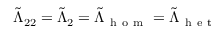<formula> <loc_0><loc_0><loc_500><loc_500>\tilde { \Lambda } _ { 2 2 } = \tilde { \Lambda } _ { 2 } = \tilde { \Lambda } _ { h o m } = \tilde { \Lambda } _ { h e t }</formula> 